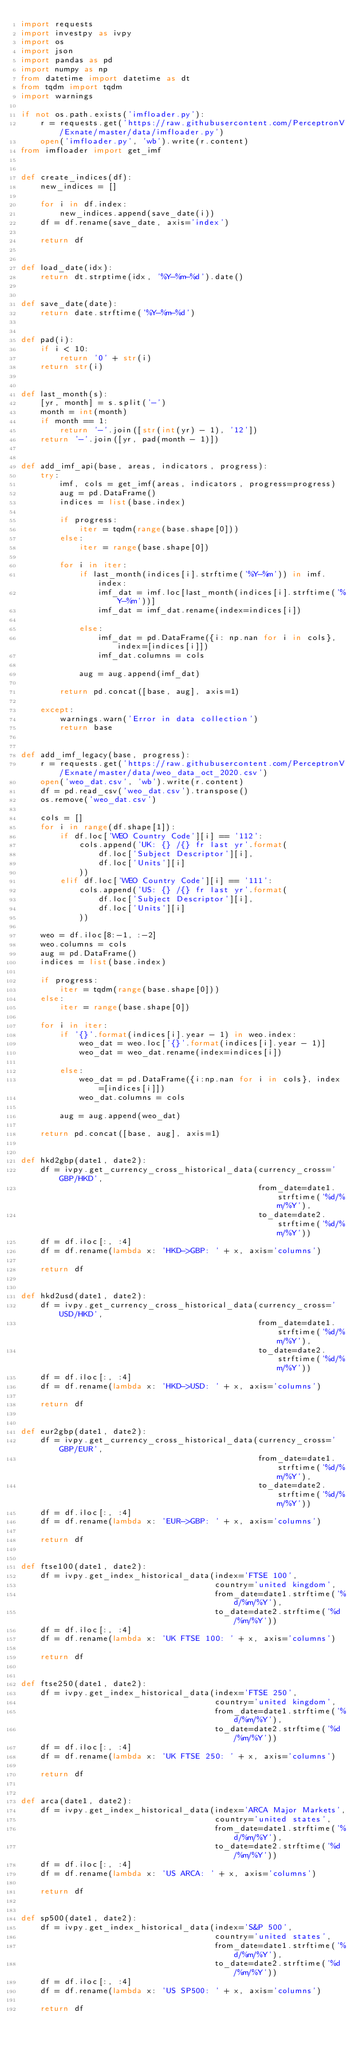<code> <loc_0><loc_0><loc_500><loc_500><_Python_>import requests
import investpy as ivpy
import os
import json
import pandas as pd
import numpy as np
from datetime import datetime as dt
from tqdm import tqdm
import warnings

if not os.path.exists('imfloader.py'):
    r = requests.get('https://raw.githubusercontent.com/PerceptronV/Exnate/master/data/imfloader.py')
    open('imfloader.py', 'wb').write(r.content)
from imfloader import get_imf


def create_indices(df):
    new_indices = []

    for i in df.index:
        new_indices.append(save_date(i))
    df = df.rename(save_date, axis='index')

    return df


def load_date(idx):
    return dt.strptime(idx, '%Y-%m-%d').date()


def save_date(date):
    return date.strftime('%Y-%m-%d')


def pad(i):
    if i < 10:
        return '0' + str(i)
    return str(i)


def last_month(s):
    [yr, month] = s.split('-')
    month = int(month)
    if month == 1:
        return '-'.join([str(int(yr) - 1), '12'])
    return '-'.join([yr, pad(month - 1)])


def add_imf_api(base, areas, indicators, progress):
    try:
        imf, cols = get_imf(areas, indicators, progress=progress)
        aug = pd.DataFrame()
        indices = list(base.index)

        if progress:
            iter = tqdm(range(base.shape[0]))
        else:
            iter = range(base.shape[0])

        for i in iter:
            if last_month(indices[i].strftime('%Y-%m')) in imf.index:
                imf_dat = imf.loc[last_month(indices[i].strftime('%Y-%m'))]
                imf_dat = imf_dat.rename(index=indices[i])

            else:
                imf_dat = pd.DataFrame({i: np.nan for i in cols}, index=[indices[i]])
                imf_dat.columns = cols

            aug = aug.append(imf_dat)

        return pd.concat([base, aug], axis=1)

    except:
        warnings.warn('Error in data collection')
        return base


def add_imf_legacy(base, progress):
    r = requests.get('https://raw.githubusercontent.com/PerceptronV/Exnate/master/data/weo_data_oct_2020.csv')
    open('weo_dat.csv', 'wb').write(r.content)
    df = pd.read_csv('weo_dat.csv').transpose()
    os.remove('weo_dat.csv')

    cols = []
    for i in range(df.shape[1]):
        if df.loc['WEO Country Code'][i] == '112':
            cols.append('UK: {} /{} fr last yr'.format(
                df.loc['Subject Descriptor'][i],
                df.loc['Units'][i]
            ))
        elif df.loc['WEO Country Code'][i] == '111':
            cols.append('US: {} /{} fr last yr'.format(
                df.loc['Subject Descriptor'][i],
                df.loc['Units'][i]
            ))

    weo = df.iloc[8:-1, :-2]
    weo.columns = cols
    aug = pd.DataFrame()
    indices = list(base.index)

    if progress:
        iter = tqdm(range(base.shape[0]))
    else:
        iter = range(base.shape[0])

    for i in iter:
        if '{}'.format(indices[i].year - 1) in weo.index:
            weo_dat = weo.loc['{}'.format(indices[i].year - 1)]
            weo_dat = weo_dat.rename(index=indices[i])

        else:
            weo_dat = pd.DataFrame({i:np.nan for i in cols}, index=[indices[i]])
            weo_dat.columns = cols

        aug = aug.append(weo_dat)

    return pd.concat([base, aug], axis=1)


def hkd2gbp(date1, date2):
    df = ivpy.get_currency_cross_historical_data(currency_cross='GBP/HKD',
                                                 from_date=date1.strftime('%d/%m/%Y'),
                                                 to_date=date2.strftime('%d/%m/%Y'))
    df = df.iloc[:, :4]
    df = df.rename(lambda x: 'HKD->GBP: ' + x, axis='columns')

    return df


def hkd2usd(date1, date2):
    df = ivpy.get_currency_cross_historical_data(currency_cross='USD/HKD',
                                                 from_date=date1.strftime('%d/%m/%Y'),
                                                 to_date=date2.strftime('%d/%m/%Y'))
    df = df.iloc[:, :4]
    df = df.rename(lambda x: 'HKD->USD: ' + x, axis='columns')

    return df


def eur2gbp(date1, date2):
    df = ivpy.get_currency_cross_historical_data(currency_cross='GBP/EUR',
                                                 from_date=date1.strftime('%d/%m/%Y'),
                                                 to_date=date2.strftime('%d/%m/%Y'))
    df = df.iloc[:, :4]
    df = df.rename(lambda x: 'EUR->GBP: ' + x, axis='columns')

    return df


def ftse100(date1, date2):
    df = ivpy.get_index_historical_data(index='FTSE 100',
                                        country='united kingdom',
                                        from_date=date1.strftime('%d/%m/%Y'),
                                        to_date=date2.strftime('%d/%m/%Y'))
    df = df.iloc[:, :4]
    df = df.rename(lambda x: 'UK FTSE 100: ' + x, axis='columns')

    return df


def ftse250(date1, date2):
    df = ivpy.get_index_historical_data(index='FTSE 250',
                                        country='united kingdom',
                                        from_date=date1.strftime('%d/%m/%Y'),
                                        to_date=date2.strftime('%d/%m/%Y'))
    df = df.iloc[:, :4]
    df = df.rename(lambda x: 'UK FTSE 250: ' + x, axis='columns')

    return df


def arca(date1, date2):
    df = ivpy.get_index_historical_data(index='ARCA Major Markets',
                                        country='united states',
                                        from_date=date1.strftime('%d/%m/%Y'),
                                        to_date=date2.strftime('%d/%m/%Y'))
    df = df.iloc[:, :4]
    df = df.rename(lambda x: 'US ARCA: ' + x, axis='columns')

    return df


def sp500(date1, date2):
    df = ivpy.get_index_historical_data(index='S&P 500',
                                        country='united states',
                                        from_date=date1.strftime('%d/%m/%Y'),
                                        to_date=date2.strftime('%d/%m/%Y'))
    df = df.iloc[:, :4]
    df = df.rename(lambda x: 'US SP500: ' + x, axis='columns')

    return df

</code> 